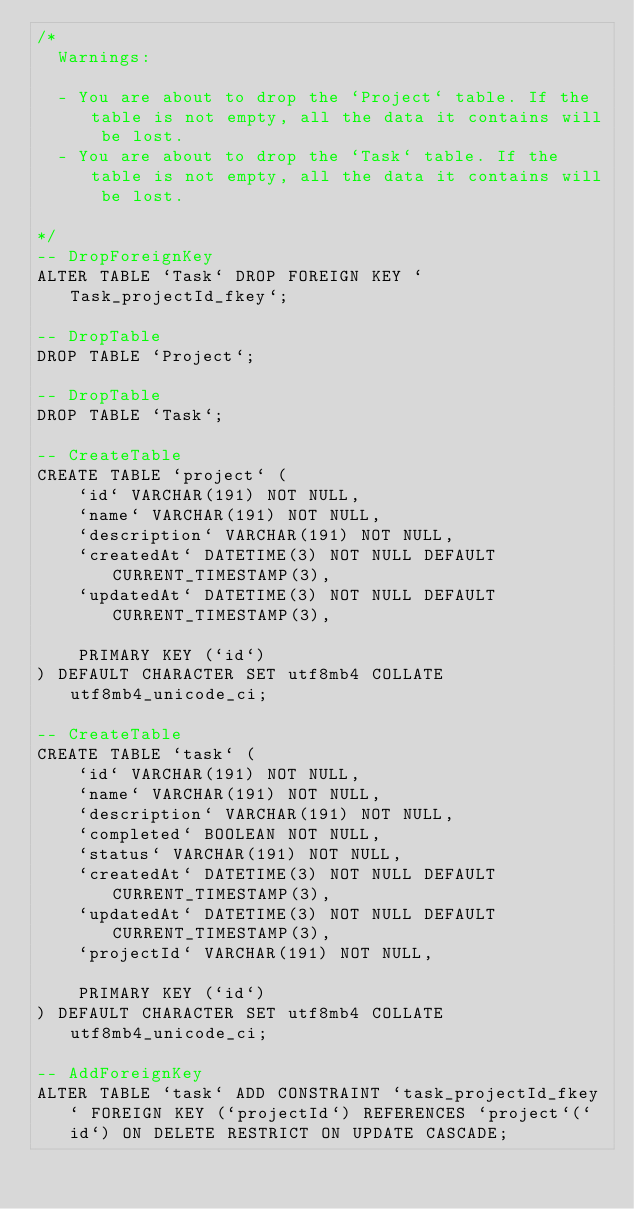Convert code to text. <code><loc_0><loc_0><loc_500><loc_500><_SQL_>/*
  Warnings:

  - You are about to drop the `Project` table. If the table is not empty, all the data it contains will be lost.
  - You are about to drop the `Task` table. If the table is not empty, all the data it contains will be lost.

*/
-- DropForeignKey
ALTER TABLE `Task` DROP FOREIGN KEY `Task_projectId_fkey`;

-- DropTable
DROP TABLE `Project`;

-- DropTable
DROP TABLE `Task`;

-- CreateTable
CREATE TABLE `project` (
    `id` VARCHAR(191) NOT NULL,
    `name` VARCHAR(191) NOT NULL,
    `description` VARCHAR(191) NOT NULL,
    `createdAt` DATETIME(3) NOT NULL DEFAULT CURRENT_TIMESTAMP(3),
    `updatedAt` DATETIME(3) NOT NULL DEFAULT CURRENT_TIMESTAMP(3),

    PRIMARY KEY (`id`)
) DEFAULT CHARACTER SET utf8mb4 COLLATE utf8mb4_unicode_ci;

-- CreateTable
CREATE TABLE `task` (
    `id` VARCHAR(191) NOT NULL,
    `name` VARCHAR(191) NOT NULL,
    `description` VARCHAR(191) NOT NULL,
    `completed` BOOLEAN NOT NULL,
    `status` VARCHAR(191) NOT NULL,
    `createdAt` DATETIME(3) NOT NULL DEFAULT CURRENT_TIMESTAMP(3),
    `updatedAt` DATETIME(3) NOT NULL DEFAULT CURRENT_TIMESTAMP(3),
    `projectId` VARCHAR(191) NOT NULL,

    PRIMARY KEY (`id`)
) DEFAULT CHARACTER SET utf8mb4 COLLATE utf8mb4_unicode_ci;

-- AddForeignKey
ALTER TABLE `task` ADD CONSTRAINT `task_projectId_fkey` FOREIGN KEY (`projectId`) REFERENCES `project`(`id`) ON DELETE RESTRICT ON UPDATE CASCADE;
</code> 